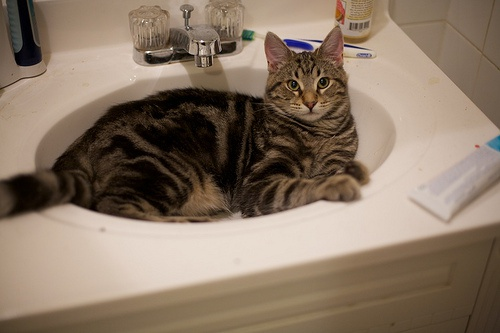Describe the objects in this image and their specific colors. I can see sink in black, tan, and lightgray tones, cat in black, maroon, and gray tones, and toothbrush in black, tan, darkgray, and navy tones in this image. 